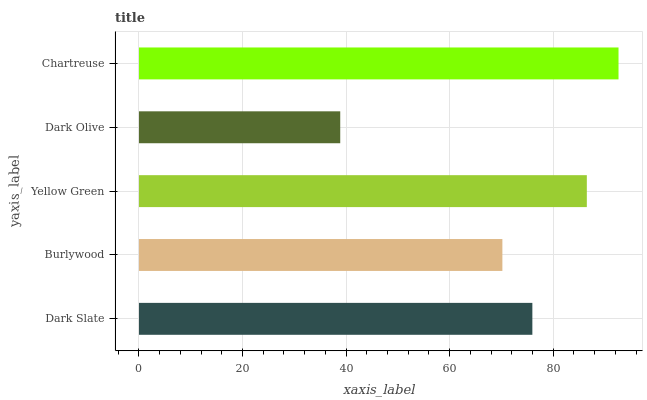Is Dark Olive the minimum?
Answer yes or no. Yes. Is Chartreuse the maximum?
Answer yes or no. Yes. Is Burlywood the minimum?
Answer yes or no. No. Is Burlywood the maximum?
Answer yes or no. No. Is Dark Slate greater than Burlywood?
Answer yes or no. Yes. Is Burlywood less than Dark Slate?
Answer yes or no. Yes. Is Burlywood greater than Dark Slate?
Answer yes or no. No. Is Dark Slate less than Burlywood?
Answer yes or no. No. Is Dark Slate the high median?
Answer yes or no. Yes. Is Dark Slate the low median?
Answer yes or no. Yes. Is Burlywood the high median?
Answer yes or no. No. Is Chartreuse the low median?
Answer yes or no. No. 